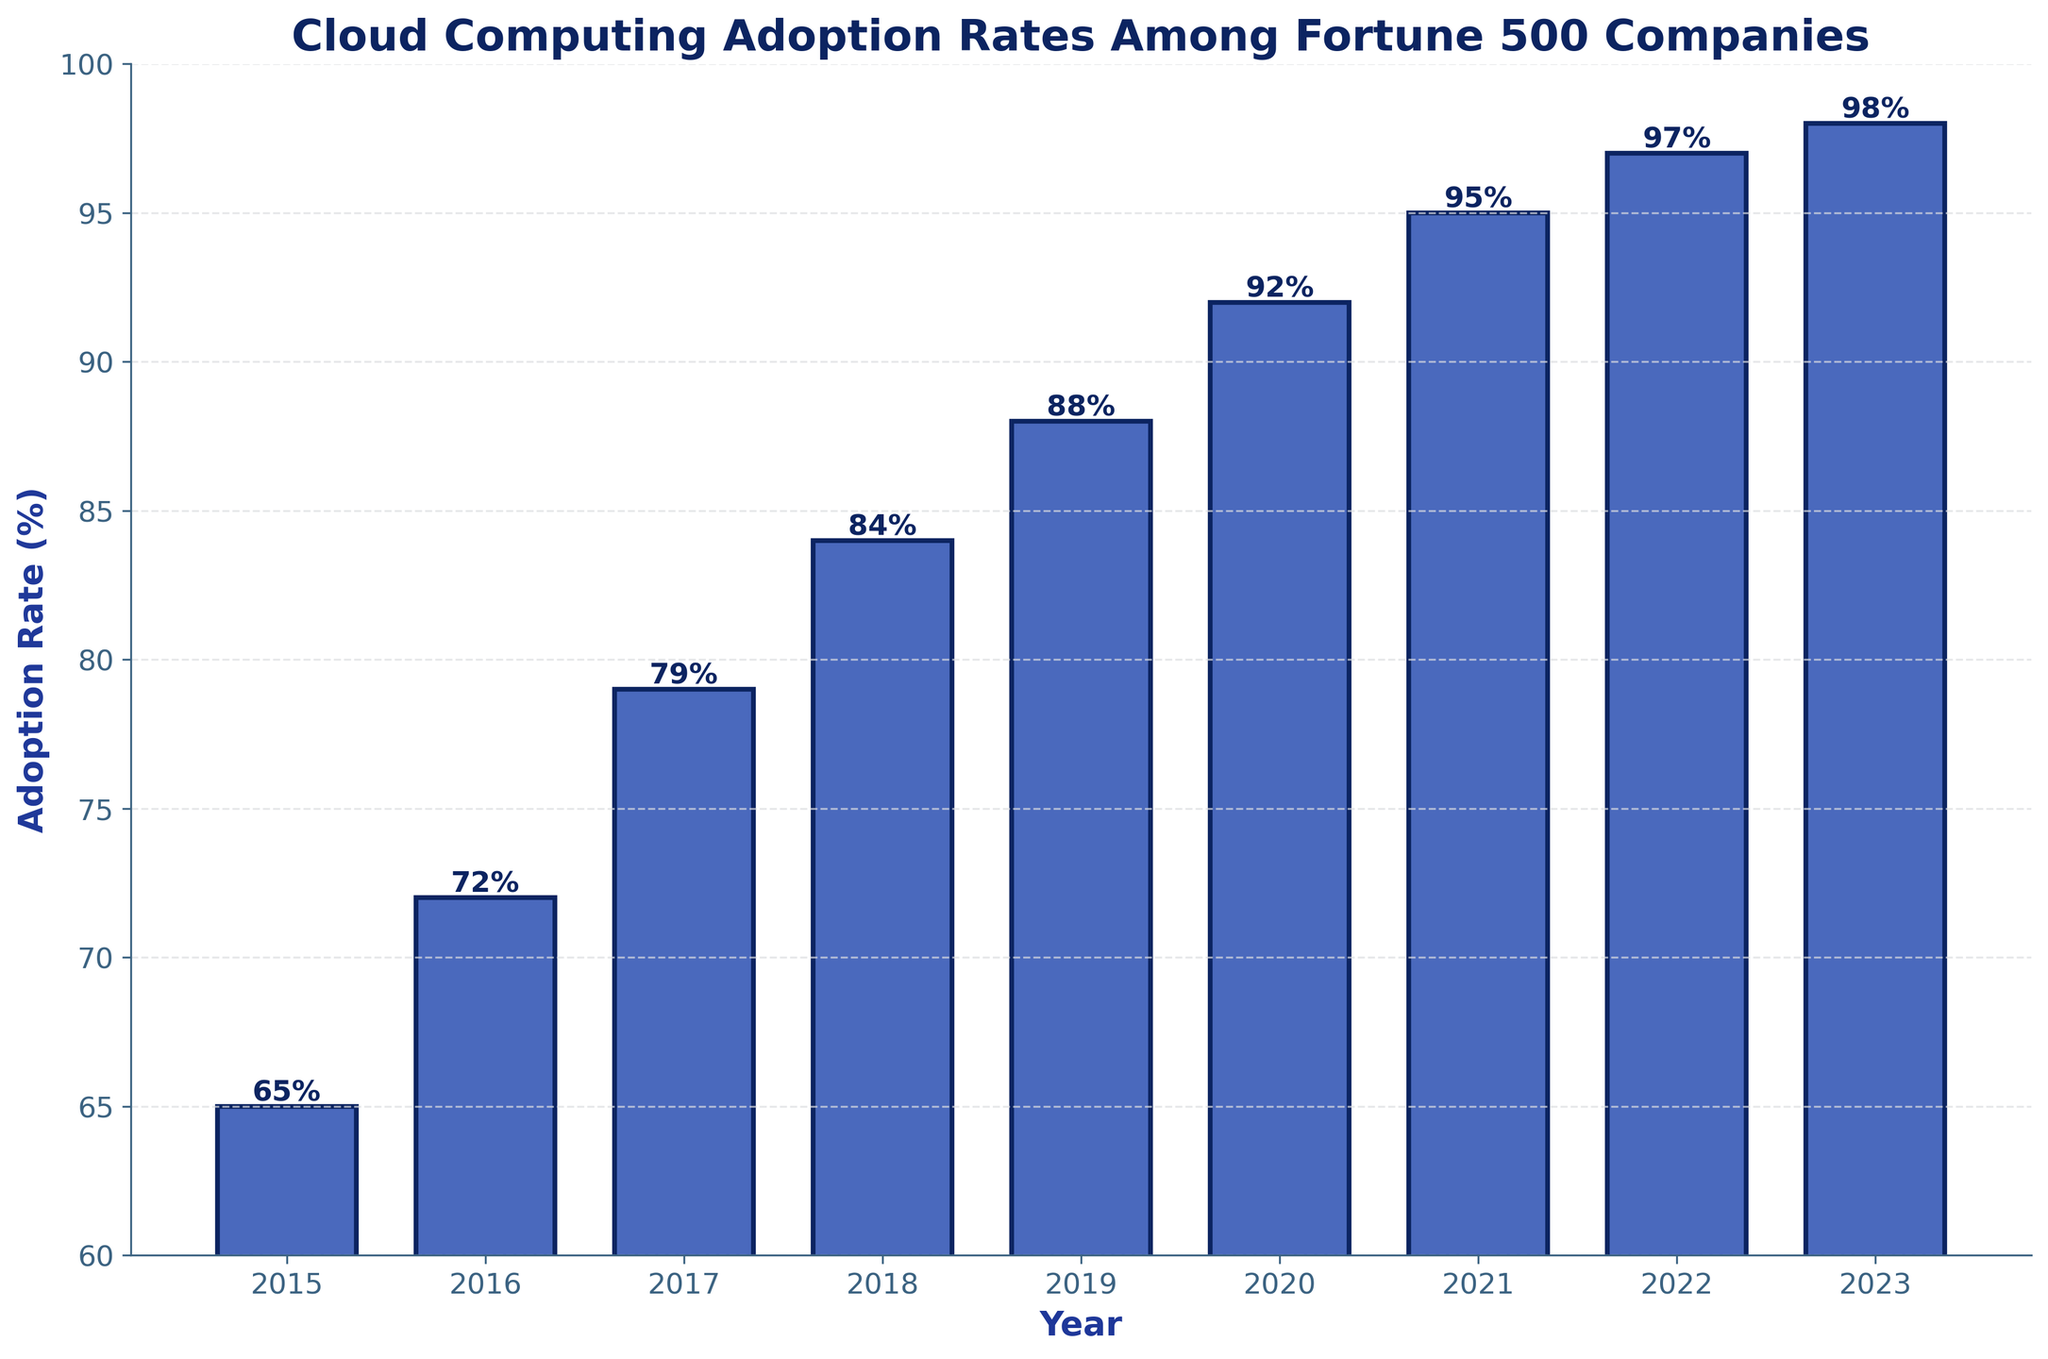What is the adoption rate of cloud computing among Fortune 500 companies in 2020? Look at the bar representing 2020 and find the number labeled on top of the bar.
Answer: 92% What is the overall trend in cloud computing adoption from 2015 to 2023? Observe the heights of the bars from 2015 to 2023. Note that each subsequent bar is taller than the previous one.
Answer: Increasing In which year did cloud computing adoption first surpass 90% among Fortune 500 companies? Find the first bar that has a value greater than 90%.
Answer: 2020 What is the percentage increase in adoption rate from 2017 to 2023? Subtract the adoption rate in 2017 from the adoption rate in 2023: 98% - 79% = 19%.
Answer: 19% How many years did it take for the adoption rate to increase from 72% to 97%? Identify the years for 72% (2016) and 97% (2022), then calculate the difference in years: 2022 - 2016 = 6 years.
Answer: 6 years Compare the adoption rates in 2015 and 2023, and determine the difference. Subtract the adoption rate in 2015 from the adoption rate in 2023: 98% - 65% = 33%.
Answer: 33% What is the average cloud computing adoption rate from 2015 to 2019? Sum the adoption rates for 2015, 2016, 2017, 2018, and 2019 and divide by 5: (65 + 72 + 79 + 84 + 88) / 5 = 77.6%.
Answer: 77.6% What is the color of the bars representing the cloud computing adoption rates? Look at the color used to fill the bars.
Answer: Blue In which year did the adoption rate surpass 80%? Locate the first bar that has a value greater than 80%.
Answer: 2018 